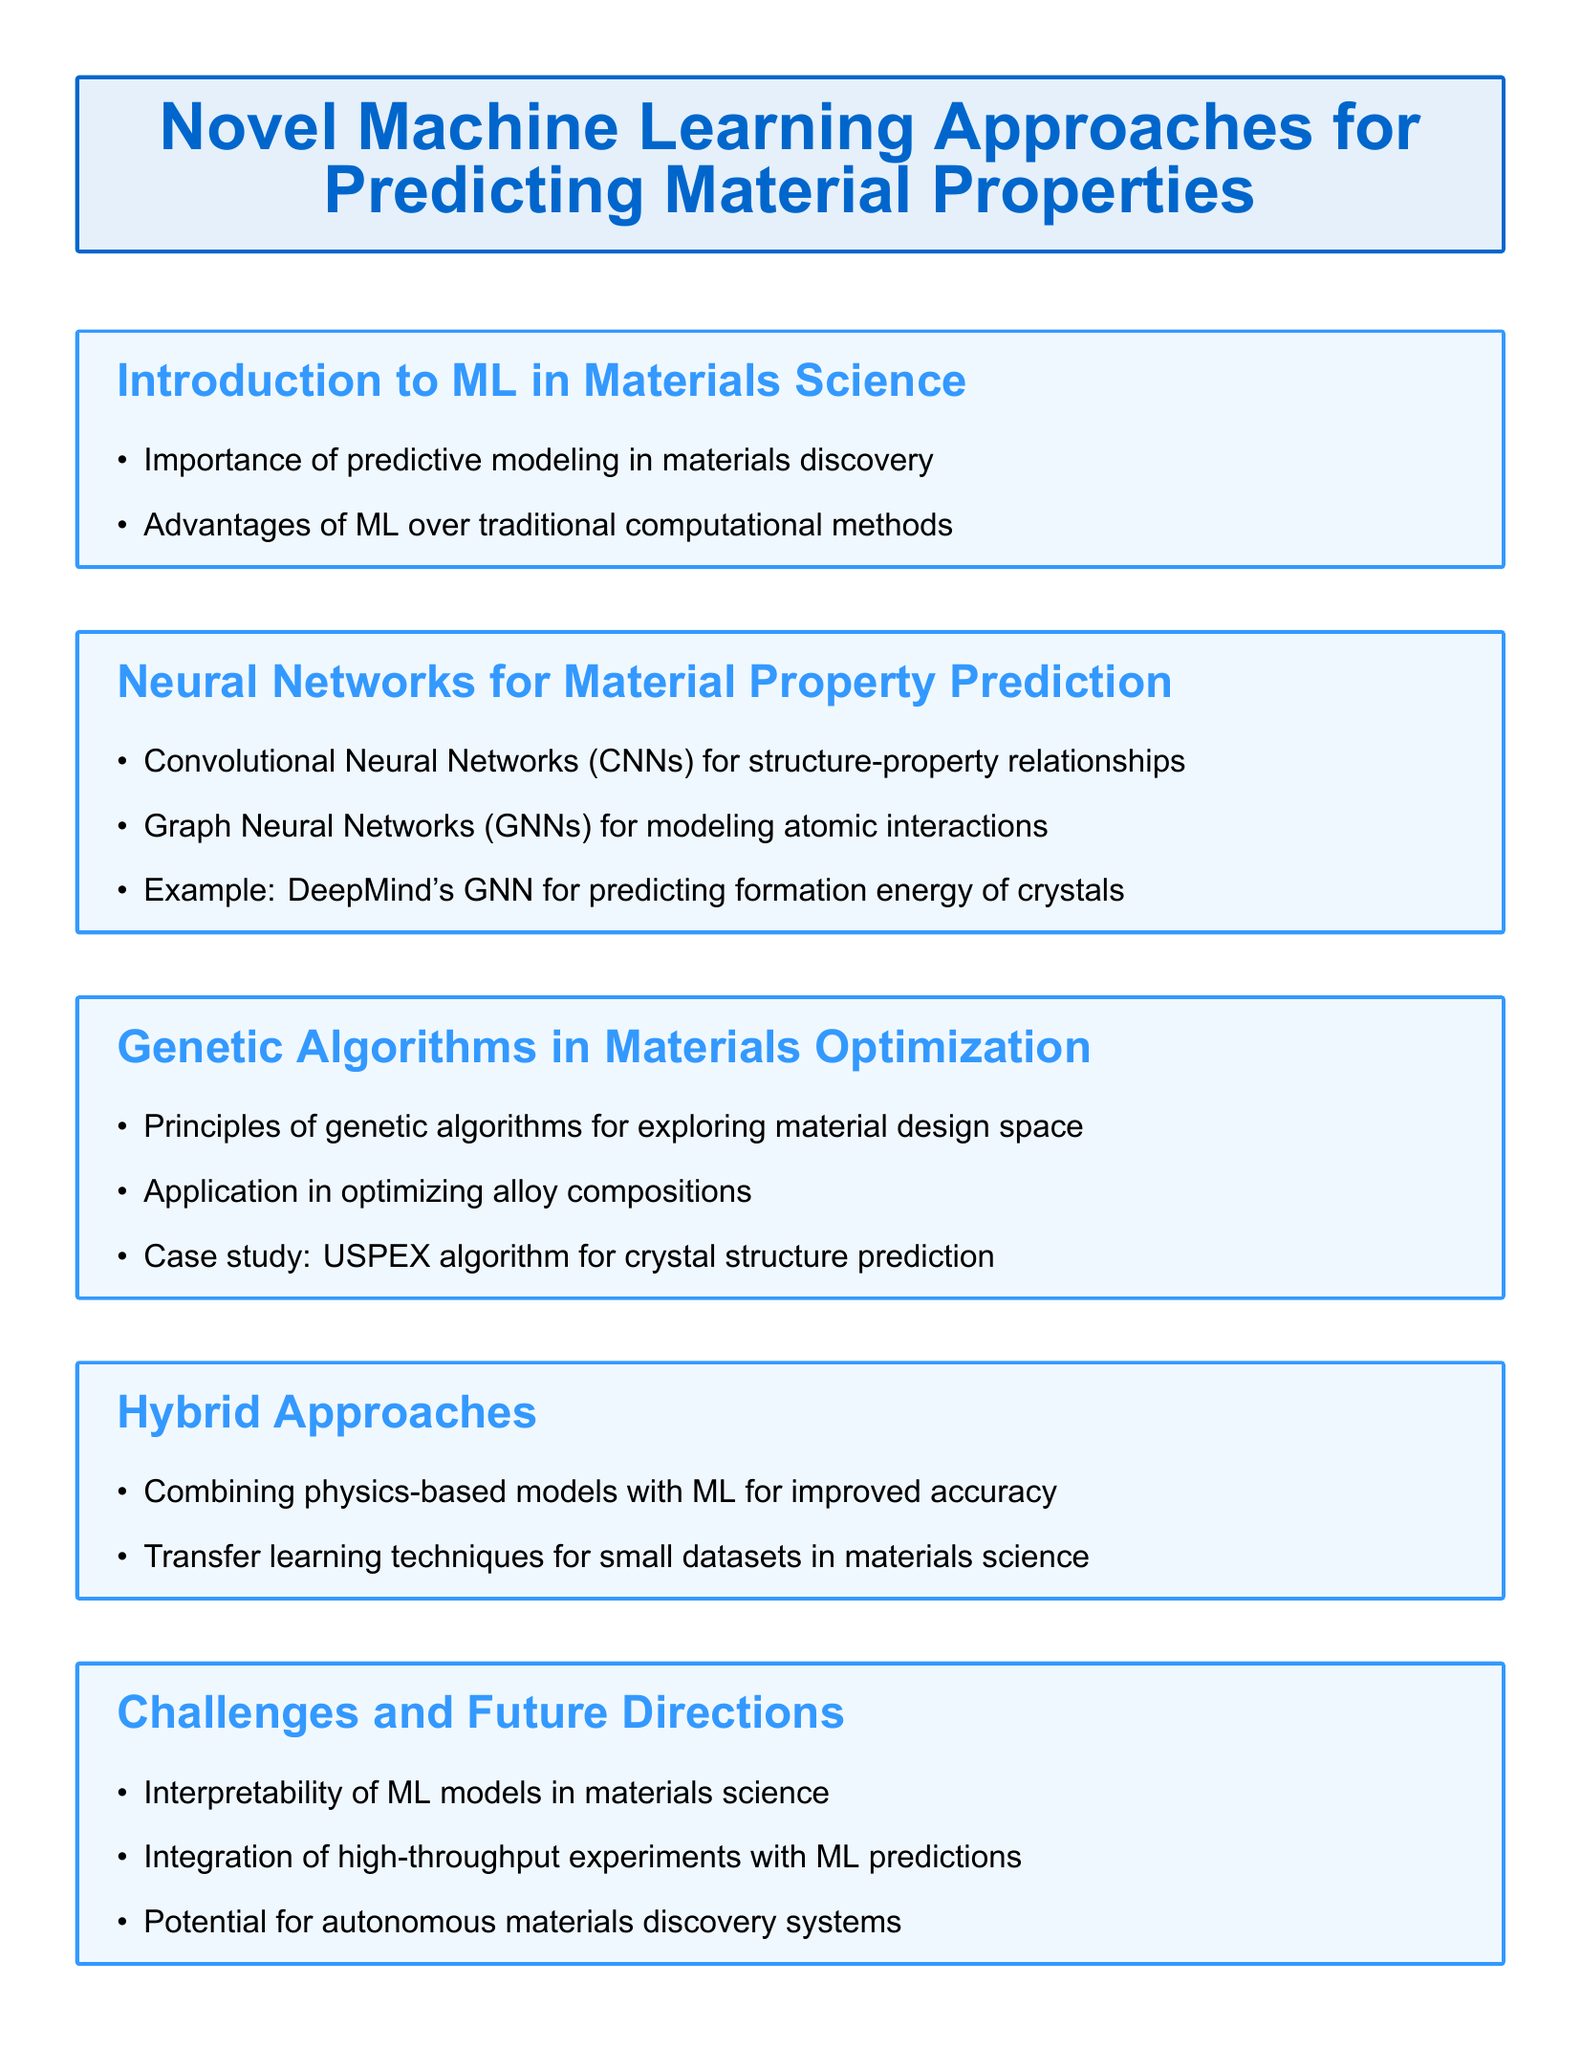What is the title of the document? The title is clearly stated at the beginning of the document.
Answer: Novel Machine Learning Approaches for Predicting Material Properties What is an application of Convolutional Neural Networks mentioned? The document states that CNNs can be used for structure-property relationships.
Answer: Structure-property relationships What algorithm is cited in the case study for crystal structure prediction? The case study specifically mentions the algorithm used for crystal structure prediction.
Answer: USPEX What is one challenge highlighted in the document? The challenges section outlines various issues, one of which is the interpretability of ML models.
Answer: Interpretability of ML models Which approach combines physics-based models with machine learning? The hybrid approaches section discusses the combination of methods for enhanced predictive power.
Answer: Hybrid Approaches How many key references are listed in the document? The document includes a specific number of references that support its content.
Answer: Three What type of neural networks are used for modeling atomic interactions? The document specifies a particular type of neural network applied in this context.
Answer: Graph Neural Networks What advantage does machine learning have over traditional methods in materials science? The document addresses an advantage that makes ML a preferable option in the field.
Answer: Advantages of ML over traditional computational methods What future direction is mentioned in the context of materials discovery systems? Towards the end of the document, a potential future direction for autonomous systems is discussed.
Answer: Autonomous materials discovery systems 